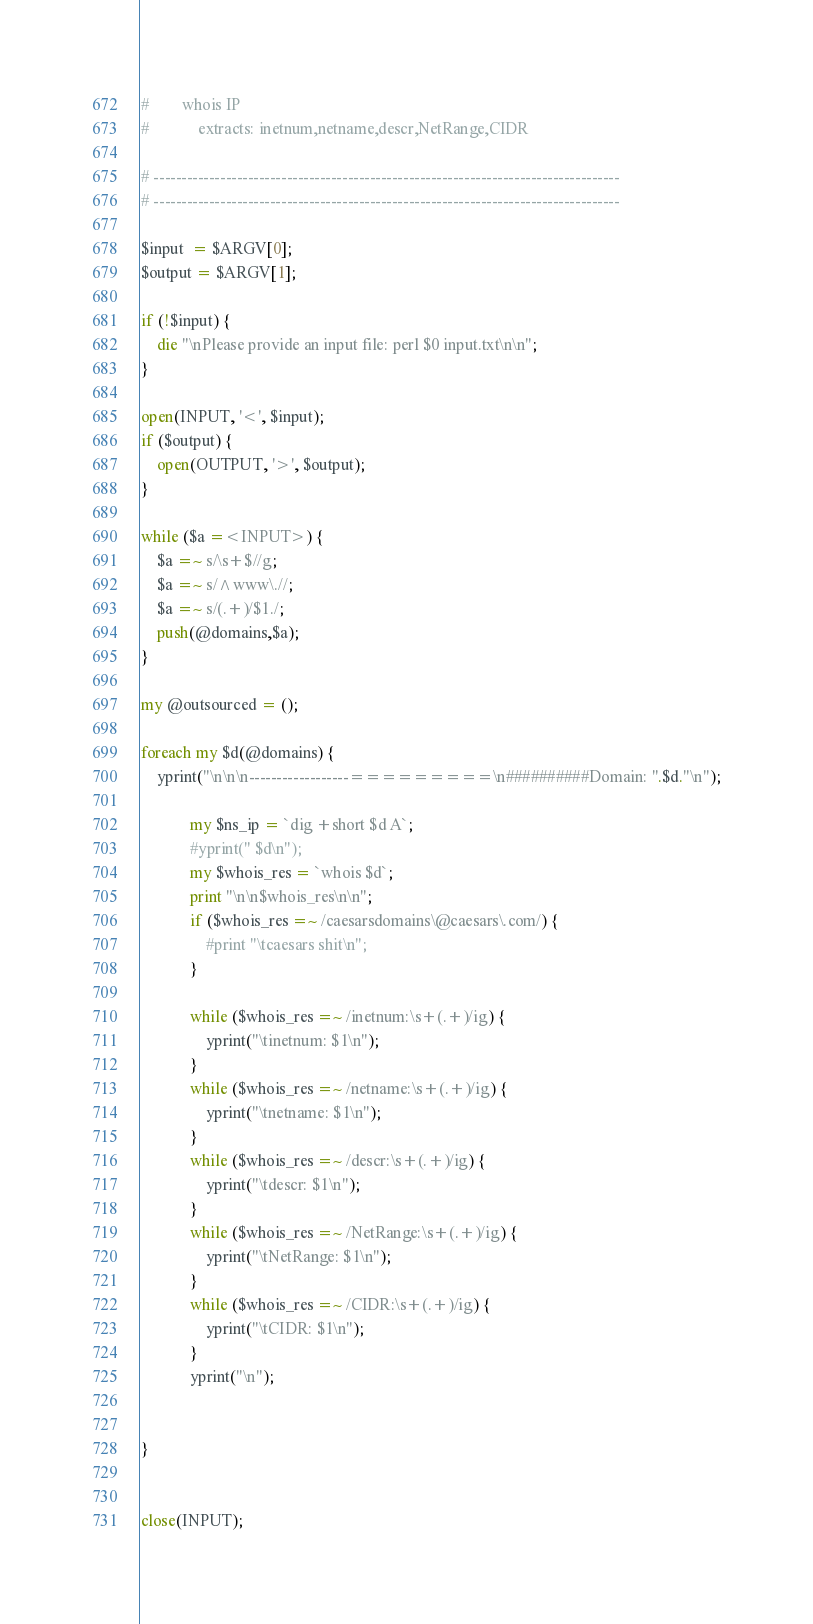<code> <loc_0><loc_0><loc_500><loc_500><_Perl_>#	 	 whois IP
#			 extracts: inetnum,netname,descr,NetRange,CIDR

# ------------------------------------------------------------------------------------
# ------------------------------------------------------------------------------------

$input  = $ARGV[0];
$output = $ARGV[1];

if (!$input) {
	die "\nPlease provide an input file: perl $0 input.txt\n\n";
}

open(INPUT, '<', $input);
if ($output) {
	open(OUTPUT, '>', $output);
}

while ($a =<INPUT>) {
	$a =~ s/\s+$//g;
	$a =~ s/^www\.//;
	$a =~ s/(.+)/$1./;
	push(@domains,$a);
}

my @outsourced = ();

foreach my $d(@domains) {
	yprint("\n\n\n------------------=========\n##########Domain: ".$d."\n");

			my $ns_ip = `dig +short $d A`;
			#yprint(" $d\n");
			my $whois_res = `whois $d`;
			print "\n\n$whois_res\n\n";
			if ($whois_res =~ /caesarsdomains\@caesars\.com/) {
				#print "\tcaesars shit\n";
			}

			while ($whois_res =~ /inetnum:\s+(.+)/ig) {
				yprint("\tinetnum: $1\n");
			}
			while ($whois_res =~ /netname:\s+(.+)/ig) {
				yprint("\tnetname: $1\n");
			}
			while ($whois_res =~ /descr:\s+(.+)/ig) {
				yprint("\tdescr: $1\n");
			}
			while ($whois_res =~ /NetRange:\s+(.+)/ig) {
				yprint("\tNetRange: $1\n");
			}
			while ($whois_res =~ /CIDR:\s+(.+)/ig) {
				yprint("\tCIDR: $1\n");
			}
			yprint("\n");


}


close(INPUT);</code> 